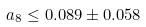Convert formula to latex. <formula><loc_0><loc_0><loc_500><loc_500>a _ { 8 } \leq 0 . 0 8 9 \pm 0 . 0 5 8</formula> 